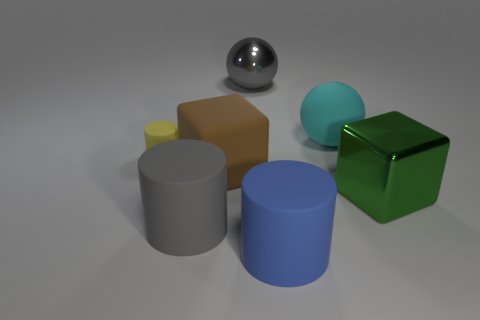Add 1 large brown matte things. How many objects exist? 8 Subtract all blocks. How many objects are left? 5 Subtract 0 purple blocks. How many objects are left? 7 Subtract all large green metal cubes. Subtract all green rubber things. How many objects are left? 6 Add 5 big gray balls. How many big gray balls are left? 6 Add 6 big green spheres. How many big green spheres exist? 6 